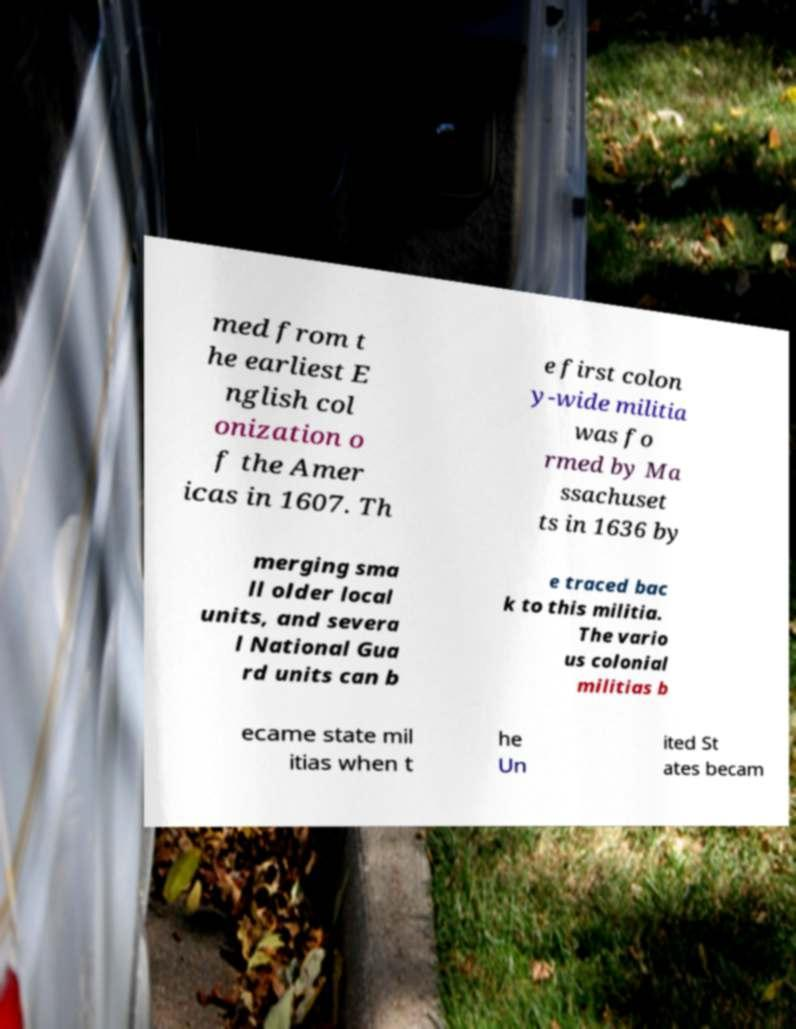There's text embedded in this image that I need extracted. Can you transcribe it verbatim? med from t he earliest E nglish col onization o f the Amer icas in 1607. Th e first colon y-wide militia was fo rmed by Ma ssachuset ts in 1636 by merging sma ll older local units, and severa l National Gua rd units can b e traced bac k to this militia. The vario us colonial militias b ecame state mil itias when t he Un ited St ates becam 